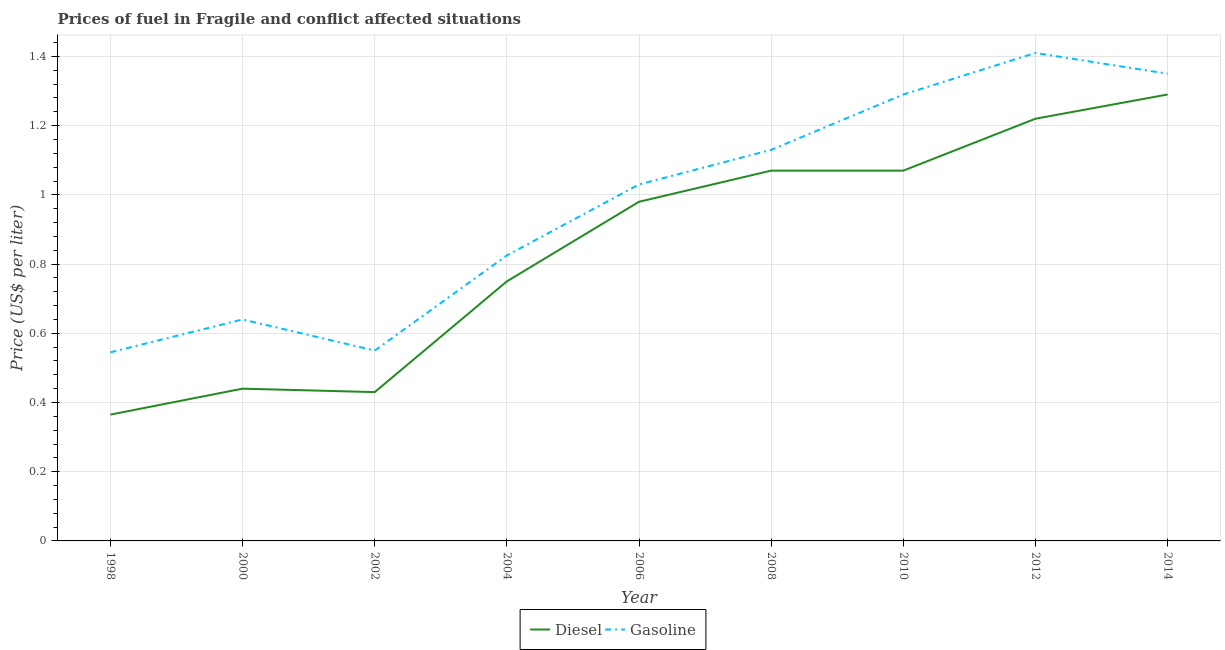Does the line corresponding to gasoline price intersect with the line corresponding to diesel price?
Make the answer very short. No. Is the number of lines equal to the number of legend labels?
Your answer should be compact. Yes. Across all years, what is the maximum diesel price?
Give a very brief answer. 1.29. Across all years, what is the minimum gasoline price?
Your answer should be very brief. 0.55. In which year was the gasoline price maximum?
Your answer should be compact. 2012. What is the total diesel price in the graph?
Offer a terse response. 7.61. What is the difference between the diesel price in 2002 and that in 2008?
Ensure brevity in your answer.  -0.64. What is the difference between the diesel price in 2004 and the gasoline price in 2000?
Offer a terse response. 0.11. What is the average gasoline price per year?
Provide a succinct answer. 0.97. In the year 2008, what is the difference between the diesel price and gasoline price?
Keep it short and to the point. -0.06. In how many years, is the gasoline price greater than 0.24000000000000002 US$ per litre?
Provide a short and direct response. 9. What is the ratio of the diesel price in 2010 to that in 2012?
Ensure brevity in your answer.  0.88. Is the difference between the diesel price in 2006 and 2012 greater than the difference between the gasoline price in 2006 and 2012?
Give a very brief answer. Yes. What is the difference between the highest and the second highest gasoline price?
Make the answer very short. 0.06. What is the difference between the highest and the lowest diesel price?
Offer a terse response. 0.93. Is the gasoline price strictly greater than the diesel price over the years?
Your answer should be compact. Yes. Is the diesel price strictly less than the gasoline price over the years?
Provide a short and direct response. Yes. How many lines are there?
Offer a very short reply. 2. Are the values on the major ticks of Y-axis written in scientific E-notation?
Make the answer very short. No. Does the graph contain any zero values?
Your answer should be compact. No. Does the graph contain grids?
Ensure brevity in your answer.  Yes. Where does the legend appear in the graph?
Keep it short and to the point. Bottom center. How many legend labels are there?
Provide a succinct answer. 2. How are the legend labels stacked?
Provide a short and direct response. Horizontal. What is the title of the graph?
Keep it short and to the point. Prices of fuel in Fragile and conflict affected situations. Does "Male entrants" appear as one of the legend labels in the graph?
Keep it short and to the point. No. What is the label or title of the X-axis?
Offer a terse response. Year. What is the label or title of the Y-axis?
Make the answer very short. Price (US$ per liter). What is the Price (US$ per liter) in Diesel in 1998?
Your answer should be very brief. 0.36. What is the Price (US$ per liter) of Gasoline in 1998?
Provide a succinct answer. 0.55. What is the Price (US$ per liter) of Diesel in 2000?
Provide a short and direct response. 0.44. What is the Price (US$ per liter) of Gasoline in 2000?
Make the answer very short. 0.64. What is the Price (US$ per liter) of Diesel in 2002?
Provide a short and direct response. 0.43. What is the Price (US$ per liter) in Gasoline in 2002?
Offer a terse response. 0.55. What is the Price (US$ per liter) in Diesel in 2004?
Your answer should be very brief. 0.75. What is the Price (US$ per liter) in Gasoline in 2004?
Ensure brevity in your answer.  0.82. What is the Price (US$ per liter) in Gasoline in 2006?
Keep it short and to the point. 1.03. What is the Price (US$ per liter) in Diesel in 2008?
Provide a short and direct response. 1.07. What is the Price (US$ per liter) of Gasoline in 2008?
Your answer should be very brief. 1.13. What is the Price (US$ per liter) in Diesel in 2010?
Your answer should be very brief. 1.07. What is the Price (US$ per liter) in Gasoline in 2010?
Offer a terse response. 1.29. What is the Price (US$ per liter) of Diesel in 2012?
Provide a short and direct response. 1.22. What is the Price (US$ per liter) of Gasoline in 2012?
Give a very brief answer. 1.41. What is the Price (US$ per liter) of Diesel in 2014?
Offer a very short reply. 1.29. What is the Price (US$ per liter) in Gasoline in 2014?
Your answer should be compact. 1.35. Across all years, what is the maximum Price (US$ per liter) of Diesel?
Keep it short and to the point. 1.29. Across all years, what is the maximum Price (US$ per liter) of Gasoline?
Give a very brief answer. 1.41. Across all years, what is the minimum Price (US$ per liter) of Diesel?
Ensure brevity in your answer.  0.36. Across all years, what is the minimum Price (US$ per liter) in Gasoline?
Ensure brevity in your answer.  0.55. What is the total Price (US$ per liter) in Diesel in the graph?
Give a very brief answer. 7.62. What is the total Price (US$ per liter) in Gasoline in the graph?
Offer a very short reply. 8.77. What is the difference between the Price (US$ per liter) of Diesel in 1998 and that in 2000?
Your answer should be compact. -0.07. What is the difference between the Price (US$ per liter) of Gasoline in 1998 and that in 2000?
Give a very brief answer. -0.1. What is the difference between the Price (US$ per liter) in Diesel in 1998 and that in 2002?
Give a very brief answer. -0.07. What is the difference between the Price (US$ per liter) of Gasoline in 1998 and that in 2002?
Keep it short and to the point. -0.01. What is the difference between the Price (US$ per liter) of Diesel in 1998 and that in 2004?
Provide a short and direct response. -0.39. What is the difference between the Price (US$ per liter) of Gasoline in 1998 and that in 2004?
Provide a succinct answer. -0.28. What is the difference between the Price (US$ per liter) in Diesel in 1998 and that in 2006?
Your response must be concise. -0.61. What is the difference between the Price (US$ per liter) in Gasoline in 1998 and that in 2006?
Ensure brevity in your answer.  -0.48. What is the difference between the Price (US$ per liter) of Diesel in 1998 and that in 2008?
Offer a terse response. -0.7. What is the difference between the Price (US$ per liter) in Gasoline in 1998 and that in 2008?
Give a very brief answer. -0.58. What is the difference between the Price (US$ per liter) in Diesel in 1998 and that in 2010?
Offer a terse response. -0.7. What is the difference between the Price (US$ per liter) of Gasoline in 1998 and that in 2010?
Offer a terse response. -0.74. What is the difference between the Price (US$ per liter) of Diesel in 1998 and that in 2012?
Give a very brief answer. -0.85. What is the difference between the Price (US$ per liter) of Gasoline in 1998 and that in 2012?
Keep it short and to the point. -0.86. What is the difference between the Price (US$ per liter) in Diesel in 1998 and that in 2014?
Your response must be concise. -0.93. What is the difference between the Price (US$ per liter) of Gasoline in 1998 and that in 2014?
Provide a short and direct response. -0.81. What is the difference between the Price (US$ per liter) of Diesel in 2000 and that in 2002?
Offer a very short reply. 0.01. What is the difference between the Price (US$ per liter) of Gasoline in 2000 and that in 2002?
Ensure brevity in your answer.  0.09. What is the difference between the Price (US$ per liter) of Diesel in 2000 and that in 2004?
Make the answer very short. -0.31. What is the difference between the Price (US$ per liter) in Gasoline in 2000 and that in 2004?
Provide a short and direct response. -0.18. What is the difference between the Price (US$ per liter) in Diesel in 2000 and that in 2006?
Your response must be concise. -0.54. What is the difference between the Price (US$ per liter) in Gasoline in 2000 and that in 2006?
Offer a terse response. -0.39. What is the difference between the Price (US$ per liter) of Diesel in 2000 and that in 2008?
Keep it short and to the point. -0.63. What is the difference between the Price (US$ per liter) in Gasoline in 2000 and that in 2008?
Offer a terse response. -0.49. What is the difference between the Price (US$ per liter) in Diesel in 2000 and that in 2010?
Provide a succinct answer. -0.63. What is the difference between the Price (US$ per liter) in Gasoline in 2000 and that in 2010?
Your answer should be very brief. -0.65. What is the difference between the Price (US$ per liter) of Diesel in 2000 and that in 2012?
Your answer should be compact. -0.78. What is the difference between the Price (US$ per liter) in Gasoline in 2000 and that in 2012?
Ensure brevity in your answer.  -0.77. What is the difference between the Price (US$ per liter) of Diesel in 2000 and that in 2014?
Your answer should be very brief. -0.85. What is the difference between the Price (US$ per liter) of Gasoline in 2000 and that in 2014?
Make the answer very short. -0.71. What is the difference between the Price (US$ per liter) in Diesel in 2002 and that in 2004?
Your answer should be very brief. -0.32. What is the difference between the Price (US$ per liter) of Gasoline in 2002 and that in 2004?
Provide a short and direct response. -0.28. What is the difference between the Price (US$ per liter) in Diesel in 2002 and that in 2006?
Your answer should be compact. -0.55. What is the difference between the Price (US$ per liter) in Gasoline in 2002 and that in 2006?
Offer a terse response. -0.48. What is the difference between the Price (US$ per liter) of Diesel in 2002 and that in 2008?
Make the answer very short. -0.64. What is the difference between the Price (US$ per liter) of Gasoline in 2002 and that in 2008?
Give a very brief answer. -0.58. What is the difference between the Price (US$ per liter) of Diesel in 2002 and that in 2010?
Keep it short and to the point. -0.64. What is the difference between the Price (US$ per liter) of Gasoline in 2002 and that in 2010?
Keep it short and to the point. -0.74. What is the difference between the Price (US$ per liter) of Diesel in 2002 and that in 2012?
Your answer should be very brief. -0.79. What is the difference between the Price (US$ per liter) in Gasoline in 2002 and that in 2012?
Offer a terse response. -0.86. What is the difference between the Price (US$ per liter) of Diesel in 2002 and that in 2014?
Your answer should be very brief. -0.86. What is the difference between the Price (US$ per liter) of Diesel in 2004 and that in 2006?
Your response must be concise. -0.23. What is the difference between the Price (US$ per liter) in Gasoline in 2004 and that in 2006?
Provide a short and direct response. -0.2. What is the difference between the Price (US$ per liter) in Diesel in 2004 and that in 2008?
Offer a very short reply. -0.32. What is the difference between the Price (US$ per liter) of Gasoline in 2004 and that in 2008?
Your answer should be compact. -0.3. What is the difference between the Price (US$ per liter) of Diesel in 2004 and that in 2010?
Your response must be concise. -0.32. What is the difference between the Price (US$ per liter) of Gasoline in 2004 and that in 2010?
Offer a terse response. -0.47. What is the difference between the Price (US$ per liter) in Diesel in 2004 and that in 2012?
Provide a succinct answer. -0.47. What is the difference between the Price (US$ per liter) of Gasoline in 2004 and that in 2012?
Make the answer very short. -0.58. What is the difference between the Price (US$ per liter) in Diesel in 2004 and that in 2014?
Your response must be concise. -0.54. What is the difference between the Price (US$ per liter) in Gasoline in 2004 and that in 2014?
Your response must be concise. -0.53. What is the difference between the Price (US$ per liter) in Diesel in 2006 and that in 2008?
Your answer should be very brief. -0.09. What is the difference between the Price (US$ per liter) in Diesel in 2006 and that in 2010?
Provide a short and direct response. -0.09. What is the difference between the Price (US$ per liter) of Gasoline in 2006 and that in 2010?
Your response must be concise. -0.26. What is the difference between the Price (US$ per liter) in Diesel in 2006 and that in 2012?
Give a very brief answer. -0.24. What is the difference between the Price (US$ per liter) of Gasoline in 2006 and that in 2012?
Ensure brevity in your answer.  -0.38. What is the difference between the Price (US$ per liter) in Diesel in 2006 and that in 2014?
Give a very brief answer. -0.31. What is the difference between the Price (US$ per liter) in Gasoline in 2006 and that in 2014?
Your answer should be very brief. -0.32. What is the difference between the Price (US$ per liter) in Diesel in 2008 and that in 2010?
Offer a very short reply. 0. What is the difference between the Price (US$ per liter) of Gasoline in 2008 and that in 2010?
Keep it short and to the point. -0.16. What is the difference between the Price (US$ per liter) in Diesel in 2008 and that in 2012?
Ensure brevity in your answer.  -0.15. What is the difference between the Price (US$ per liter) in Gasoline in 2008 and that in 2012?
Your response must be concise. -0.28. What is the difference between the Price (US$ per liter) of Diesel in 2008 and that in 2014?
Your answer should be compact. -0.22. What is the difference between the Price (US$ per liter) of Gasoline in 2008 and that in 2014?
Give a very brief answer. -0.22. What is the difference between the Price (US$ per liter) of Diesel in 2010 and that in 2012?
Your answer should be compact. -0.15. What is the difference between the Price (US$ per liter) of Gasoline in 2010 and that in 2012?
Offer a very short reply. -0.12. What is the difference between the Price (US$ per liter) in Diesel in 2010 and that in 2014?
Ensure brevity in your answer.  -0.22. What is the difference between the Price (US$ per liter) of Gasoline in 2010 and that in 2014?
Provide a short and direct response. -0.06. What is the difference between the Price (US$ per liter) in Diesel in 2012 and that in 2014?
Provide a short and direct response. -0.07. What is the difference between the Price (US$ per liter) of Diesel in 1998 and the Price (US$ per liter) of Gasoline in 2000?
Offer a terse response. -0.28. What is the difference between the Price (US$ per liter) in Diesel in 1998 and the Price (US$ per liter) in Gasoline in 2002?
Your response must be concise. -0.18. What is the difference between the Price (US$ per liter) of Diesel in 1998 and the Price (US$ per liter) of Gasoline in 2004?
Keep it short and to the point. -0.46. What is the difference between the Price (US$ per liter) of Diesel in 1998 and the Price (US$ per liter) of Gasoline in 2006?
Your answer should be compact. -0.67. What is the difference between the Price (US$ per liter) in Diesel in 1998 and the Price (US$ per liter) in Gasoline in 2008?
Keep it short and to the point. -0.77. What is the difference between the Price (US$ per liter) in Diesel in 1998 and the Price (US$ per liter) in Gasoline in 2010?
Ensure brevity in your answer.  -0.93. What is the difference between the Price (US$ per liter) in Diesel in 1998 and the Price (US$ per liter) in Gasoline in 2012?
Your answer should be very brief. -1.04. What is the difference between the Price (US$ per liter) of Diesel in 1998 and the Price (US$ per liter) of Gasoline in 2014?
Your answer should be very brief. -0.98. What is the difference between the Price (US$ per liter) in Diesel in 2000 and the Price (US$ per liter) in Gasoline in 2002?
Ensure brevity in your answer.  -0.11. What is the difference between the Price (US$ per liter) in Diesel in 2000 and the Price (US$ per liter) in Gasoline in 2004?
Keep it short and to the point. -0.39. What is the difference between the Price (US$ per liter) of Diesel in 2000 and the Price (US$ per liter) of Gasoline in 2006?
Offer a terse response. -0.59. What is the difference between the Price (US$ per liter) in Diesel in 2000 and the Price (US$ per liter) in Gasoline in 2008?
Offer a very short reply. -0.69. What is the difference between the Price (US$ per liter) of Diesel in 2000 and the Price (US$ per liter) of Gasoline in 2010?
Ensure brevity in your answer.  -0.85. What is the difference between the Price (US$ per liter) in Diesel in 2000 and the Price (US$ per liter) in Gasoline in 2012?
Your answer should be very brief. -0.97. What is the difference between the Price (US$ per liter) in Diesel in 2000 and the Price (US$ per liter) in Gasoline in 2014?
Ensure brevity in your answer.  -0.91. What is the difference between the Price (US$ per liter) of Diesel in 2002 and the Price (US$ per liter) of Gasoline in 2004?
Make the answer very short. -0.4. What is the difference between the Price (US$ per liter) of Diesel in 2002 and the Price (US$ per liter) of Gasoline in 2006?
Ensure brevity in your answer.  -0.6. What is the difference between the Price (US$ per liter) of Diesel in 2002 and the Price (US$ per liter) of Gasoline in 2008?
Your response must be concise. -0.7. What is the difference between the Price (US$ per liter) in Diesel in 2002 and the Price (US$ per liter) in Gasoline in 2010?
Provide a succinct answer. -0.86. What is the difference between the Price (US$ per liter) of Diesel in 2002 and the Price (US$ per liter) of Gasoline in 2012?
Ensure brevity in your answer.  -0.98. What is the difference between the Price (US$ per liter) in Diesel in 2002 and the Price (US$ per liter) in Gasoline in 2014?
Your answer should be very brief. -0.92. What is the difference between the Price (US$ per liter) of Diesel in 2004 and the Price (US$ per liter) of Gasoline in 2006?
Make the answer very short. -0.28. What is the difference between the Price (US$ per liter) in Diesel in 2004 and the Price (US$ per liter) in Gasoline in 2008?
Ensure brevity in your answer.  -0.38. What is the difference between the Price (US$ per liter) of Diesel in 2004 and the Price (US$ per liter) of Gasoline in 2010?
Give a very brief answer. -0.54. What is the difference between the Price (US$ per liter) of Diesel in 2004 and the Price (US$ per liter) of Gasoline in 2012?
Ensure brevity in your answer.  -0.66. What is the difference between the Price (US$ per liter) of Diesel in 2004 and the Price (US$ per liter) of Gasoline in 2014?
Give a very brief answer. -0.6. What is the difference between the Price (US$ per liter) in Diesel in 2006 and the Price (US$ per liter) in Gasoline in 2010?
Provide a succinct answer. -0.31. What is the difference between the Price (US$ per liter) of Diesel in 2006 and the Price (US$ per liter) of Gasoline in 2012?
Your answer should be compact. -0.43. What is the difference between the Price (US$ per liter) in Diesel in 2006 and the Price (US$ per liter) in Gasoline in 2014?
Your answer should be compact. -0.37. What is the difference between the Price (US$ per liter) of Diesel in 2008 and the Price (US$ per liter) of Gasoline in 2010?
Make the answer very short. -0.22. What is the difference between the Price (US$ per liter) in Diesel in 2008 and the Price (US$ per liter) in Gasoline in 2012?
Make the answer very short. -0.34. What is the difference between the Price (US$ per liter) of Diesel in 2008 and the Price (US$ per liter) of Gasoline in 2014?
Provide a succinct answer. -0.28. What is the difference between the Price (US$ per liter) in Diesel in 2010 and the Price (US$ per liter) in Gasoline in 2012?
Offer a very short reply. -0.34. What is the difference between the Price (US$ per liter) of Diesel in 2010 and the Price (US$ per liter) of Gasoline in 2014?
Give a very brief answer. -0.28. What is the difference between the Price (US$ per liter) in Diesel in 2012 and the Price (US$ per liter) in Gasoline in 2014?
Offer a terse response. -0.13. What is the average Price (US$ per liter) in Diesel per year?
Make the answer very short. 0.85. What is the average Price (US$ per liter) in Gasoline per year?
Your answer should be compact. 0.97. In the year 1998, what is the difference between the Price (US$ per liter) of Diesel and Price (US$ per liter) of Gasoline?
Keep it short and to the point. -0.18. In the year 2002, what is the difference between the Price (US$ per liter) of Diesel and Price (US$ per liter) of Gasoline?
Your answer should be compact. -0.12. In the year 2004, what is the difference between the Price (US$ per liter) of Diesel and Price (US$ per liter) of Gasoline?
Give a very brief answer. -0.07. In the year 2006, what is the difference between the Price (US$ per liter) in Diesel and Price (US$ per liter) in Gasoline?
Offer a very short reply. -0.05. In the year 2008, what is the difference between the Price (US$ per liter) in Diesel and Price (US$ per liter) in Gasoline?
Offer a terse response. -0.06. In the year 2010, what is the difference between the Price (US$ per liter) in Diesel and Price (US$ per liter) in Gasoline?
Your answer should be very brief. -0.22. In the year 2012, what is the difference between the Price (US$ per liter) in Diesel and Price (US$ per liter) in Gasoline?
Give a very brief answer. -0.19. In the year 2014, what is the difference between the Price (US$ per liter) in Diesel and Price (US$ per liter) in Gasoline?
Ensure brevity in your answer.  -0.06. What is the ratio of the Price (US$ per liter) in Diesel in 1998 to that in 2000?
Give a very brief answer. 0.83. What is the ratio of the Price (US$ per liter) of Gasoline in 1998 to that in 2000?
Your response must be concise. 0.85. What is the ratio of the Price (US$ per liter) in Diesel in 1998 to that in 2002?
Ensure brevity in your answer.  0.85. What is the ratio of the Price (US$ per liter) of Gasoline in 1998 to that in 2002?
Provide a short and direct response. 0.99. What is the ratio of the Price (US$ per liter) of Diesel in 1998 to that in 2004?
Give a very brief answer. 0.49. What is the ratio of the Price (US$ per liter) of Gasoline in 1998 to that in 2004?
Ensure brevity in your answer.  0.66. What is the ratio of the Price (US$ per liter) of Diesel in 1998 to that in 2006?
Keep it short and to the point. 0.37. What is the ratio of the Price (US$ per liter) of Gasoline in 1998 to that in 2006?
Offer a terse response. 0.53. What is the ratio of the Price (US$ per liter) in Diesel in 1998 to that in 2008?
Keep it short and to the point. 0.34. What is the ratio of the Price (US$ per liter) of Gasoline in 1998 to that in 2008?
Provide a short and direct response. 0.48. What is the ratio of the Price (US$ per liter) of Diesel in 1998 to that in 2010?
Offer a very short reply. 0.34. What is the ratio of the Price (US$ per liter) in Gasoline in 1998 to that in 2010?
Your answer should be very brief. 0.42. What is the ratio of the Price (US$ per liter) of Diesel in 1998 to that in 2012?
Give a very brief answer. 0.3. What is the ratio of the Price (US$ per liter) of Gasoline in 1998 to that in 2012?
Ensure brevity in your answer.  0.39. What is the ratio of the Price (US$ per liter) of Diesel in 1998 to that in 2014?
Provide a succinct answer. 0.28. What is the ratio of the Price (US$ per liter) in Gasoline in 1998 to that in 2014?
Keep it short and to the point. 0.4. What is the ratio of the Price (US$ per liter) of Diesel in 2000 to that in 2002?
Make the answer very short. 1.02. What is the ratio of the Price (US$ per liter) in Gasoline in 2000 to that in 2002?
Your answer should be compact. 1.16. What is the ratio of the Price (US$ per liter) in Diesel in 2000 to that in 2004?
Your answer should be compact. 0.59. What is the ratio of the Price (US$ per liter) in Gasoline in 2000 to that in 2004?
Your answer should be very brief. 0.78. What is the ratio of the Price (US$ per liter) in Diesel in 2000 to that in 2006?
Make the answer very short. 0.45. What is the ratio of the Price (US$ per liter) of Gasoline in 2000 to that in 2006?
Your answer should be very brief. 0.62. What is the ratio of the Price (US$ per liter) of Diesel in 2000 to that in 2008?
Make the answer very short. 0.41. What is the ratio of the Price (US$ per liter) of Gasoline in 2000 to that in 2008?
Provide a succinct answer. 0.57. What is the ratio of the Price (US$ per liter) in Diesel in 2000 to that in 2010?
Give a very brief answer. 0.41. What is the ratio of the Price (US$ per liter) in Gasoline in 2000 to that in 2010?
Provide a short and direct response. 0.5. What is the ratio of the Price (US$ per liter) of Diesel in 2000 to that in 2012?
Keep it short and to the point. 0.36. What is the ratio of the Price (US$ per liter) of Gasoline in 2000 to that in 2012?
Offer a very short reply. 0.45. What is the ratio of the Price (US$ per liter) of Diesel in 2000 to that in 2014?
Provide a succinct answer. 0.34. What is the ratio of the Price (US$ per liter) of Gasoline in 2000 to that in 2014?
Make the answer very short. 0.47. What is the ratio of the Price (US$ per liter) in Diesel in 2002 to that in 2004?
Give a very brief answer. 0.57. What is the ratio of the Price (US$ per liter) in Diesel in 2002 to that in 2006?
Your answer should be very brief. 0.44. What is the ratio of the Price (US$ per liter) in Gasoline in 2002 to that in 2006?
Provide a short and direct response. 0.53. What is the ratio of the Price (US$ per liter) of Diesel in 2002 to that in 2008?
Your answer should be very brief. 0.4. What is the ratio of the Price (US$ per liter) of Gasoline in 2002 to that in 2008?
Make the answer very short. 0.49. What is the ratio of the Price (US$ per liter) in Diesel in 2002 to that in 2010?
Your answer should be very brief. 0.4. What is the ratio of the Price (US$ per liter) of Gasoline in 2002 to that in 2010?
Your response must be concise. 0.43. What is the ratio of the Price (US$ per liter) of Diesel in 2002 to that in 2012?
Ensure brevity in your answer.  0.35. What is the ratio of the Price (US$ per liter) of Gasoline in 2002 to that in 2012?
Your answer should be compact. 0.39. What is the ratio of the Price (US$ per liter) in Gasoline in 2002 to that in 2014?
Provide a short and direct response. 0.41. What is the ratio of the Price (US$ per liter) of Diesel in 2004 to that in 2006?
Provide a succinct answer. 0.77. What is the ratio of the Price (US$ per liter) in Gasoline in 2004 to that in 2006?
Keep it short and to the point. 0.8. What is the ratio of the Price (US$ per liter) of Diesel in 2004 to that in 2008?
Provide a short and direct response. 0.7. What is the ratio of the Price (US$ per liter) in Gasoline in 2004 to that in 2008?
Make the answer very short. 0.73. What is the ratio of the Price (US$ per liter) of Diesel in 2004 to that in 2010?
Make the answer very short. 0.7. What is the ratio of the Price (US$ per liter) of Gasoline in 2004 to that in 2010?
Make the answer very short. 0.64. What is the ratio of the Price (US$ per liter) of Diesel in 2004 to that in 2012?
Give a very brief answer. 0.61. What is the ratio of the Price (US$ per liter) of Gasoline in 2004 to that in 2012?
Give a very brief answer. 0.59. What is the ratio of the Price (US$ per liter) in Diesel in 2004 to that in 2014?
Make the answer very short. 0.58. What is the ratio of the Price (US$ per liter) of Gasoline in 2004 to that in 2014?
Provide a short and direct response. 0.61. What is the ratio of the Price (US$ per liter) of Diesel in 2006 to that in 2008?
Provide a succinct answer. 0.92. What is the ratio of the Price (US$ per liter) of Gasoline in 2006 to that in 2008?
Keep it short and to the point. 0.91. What is the ratio of the Price (US$ per liter) in Diesel in 2006 to that in 2010?
Give a very brief answer. 0.92. What is the ratio of the Price (US$ per liter) of Gasoline in 2006 to that in 2010?
Offer a terse response. 0.8. What is the ratio of the Price (US$ per liter) in Diesel in 2006 to that in 2012?
Make the answer very short. 0.8. What is the ratio of the Price (US$ per liter) of Gasoline in 2006 to that in 2012?
Provide a succinct answer. 0.73. What is the ratio of the Price (US$ per liter) in Diesel in 2006 to that in 2014?
Provide a short and direct response. 0.76. What is the ratio of the Price (US$ per liter) of Gasoline in 2006 to that in 2014?
Keep it short and to the point. 0.76. What is the ratio of the Price (US$ per liter) of Gasoline in 2008 to that in 2010?
Your answer should be very brief. 0.88. What is the ratio of the Price (US$ per liter) of Diesel in 2008 to that in 2012?
Provide a short and direct response. 0.88. What is the ratio of the Price (US$ per liter) in Gasoline in 2008 to that in 2012?
Offer a very short reply. 0.8. What is the ratio of the Price (US$ per liter) of Diesel in 2008 to that in 2014?
Your answer should be compact. 0.83. What is the ratio of the Price (US$ per liter) of Gasoline in 2008 to that in 2014?
Your answer should be compact. 0.84. What is the ratio of the Price (US$ per liter) of Diesel in 2010 to that in 2012?
Offer a terse response. 0.88. What is the ratio of the Price (US$ per liter) of Gasoline in 2010 to that in 2012?
Offer a terse response. 0.91. What is the ratio of the Price (US$ per liter) of Diesel in 2010 to that in 2014?
Offer a terse response. 0.83. What is the ratio of the Price (US$ per liter) in Gasoline in 2010 to that in 2014?
Ensure brevity in your answer.  0.96. What is the ratio of the Price (US$ per liter) of Diesel in 2012 to that in 2014?
Offer a very short reply. 0.95. What is the ratio of the Price (US$ per liter) in Gasoline in 2012 to that in 2014?
Your response must be concise. 1.04. What is the difference between the highest and the second highest Price (US$ per liter) of Diesel?
Give a very brief answer. 0.07. What is the difference between the highest and the lowest Price (US$ per liter) of Diesel?
Give a very brief answer. 0.93. What is the difference between the highest and the lowest Price (US$ per liter) of Gasoline?
Offer a terse response. 0.86. 